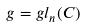Convert formula to latex. <formula><loc_0><loc_0><loc_500><loc_500>g = g l _ { n } ( C )</formula> 